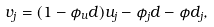Convert formula to latex. <formula><loc_0><loc_0><loc_500><loc_500>v _ { j } = ( 1 - \phi _ { u } d ) u _ { j } - \phi _ { j } d - \phi d _ { j } ,</formula> 